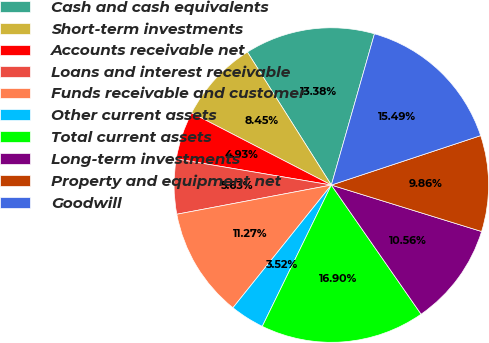<chart> <loc_0><loc_0><loc_500><loc_500><pie_chart><fcel>Cash and cash equivalents<fcel>Short-term investments<fcel>Accounts receivable net<fcel>Loans and interest receivable<fcel>Funds receivable and customer<fcel>Other current assets<fcel>Total current assets<fcel>Long-term investments<fcel>Property and equipment net<fcel>Goodwill<nl><fcel>13.38%<fcel>8.45%<fcel>4.93%<fcel>5.63%<fcel>11.27%<fcel>3.52%<fcel>16.9%<fcel>10.56%<fcel>9.86%<fcel>15.49%<nl></chart> 